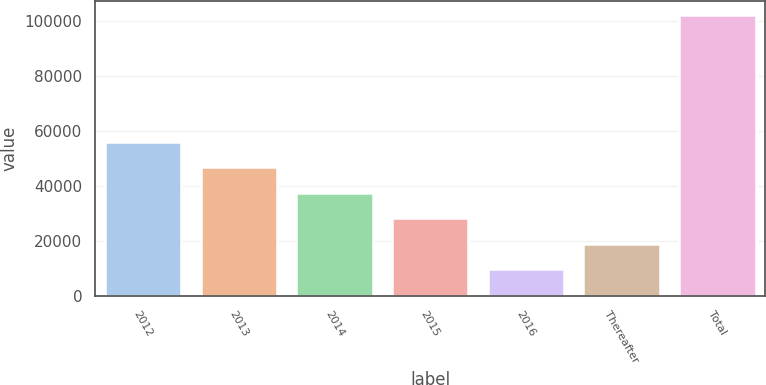<chart> <loc_0><loc_0><loc_500><loc_500><bar_chart><fcel>2012<fcel>2013<fcel>2014<fcel>2015<fcel>2016<fcel>Thereafter<fcel>Total<nl><fcel>56058<fcel>46822.6<fcel>37587.2<fcel>28351.8<fcel>9881<fcel>19116.4<fcel>102235<nl></chart> 